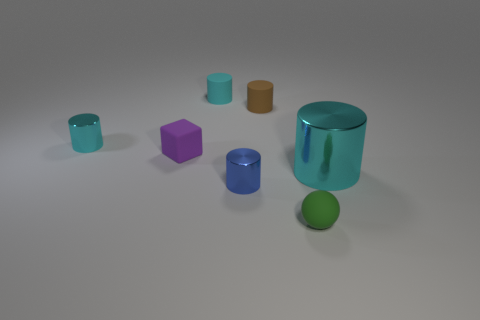What shape is the rubber thing in front of the cyan metallic cylinder that is in front of the tiny cyan metal cylinder? sphere 